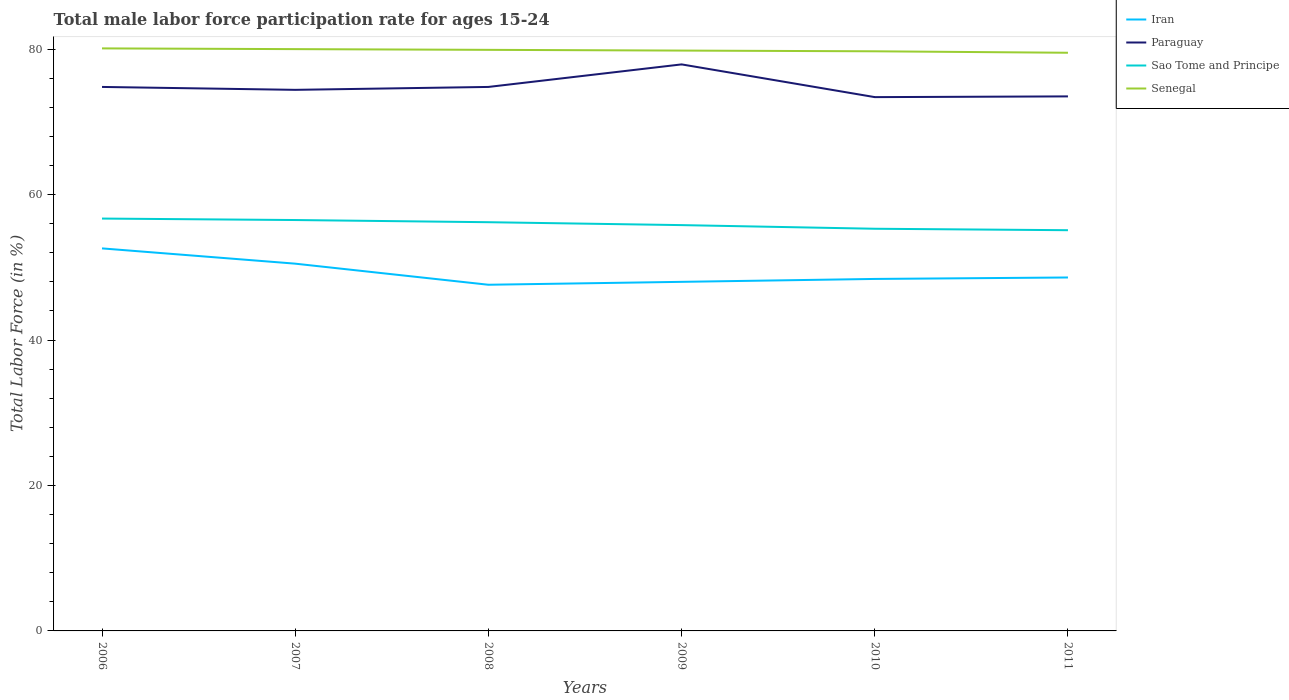How many different coloured lines are there?
Offer a very short reply. 4. Does the line corresponding to Iran intersect with the line corresponding to Senegal?
Provide a succinct answer. No. Across all years, what is the maximum male labor force participation rate in Sao Tome and Principe?
Offer a very short reply. 55.1. In which year was the male labor force participation rate in Paraguay maximum?
Give a very brief answer. 2010. What is the total male labor force participation rate in Sao Tome and Principe in the graph?
Ensure brevity in your answer.  0.3. What is the difference between the highest and the second highest male labor force participation rate in Sao Tome and Principe?
Offer a terse response. 1.6. What is the difference between the highest and the lowest male labor force participation rate in Senegal?
Provide a succinct answer. 3. How many legend labels are there?
Offer a very short reply. 4. What is the title of the graph?
Your response must be concise. Total male labor force participation rate for ages 15-24. What is the Total Labor Force (in %) of Iran in 2006?
Your answer should be very brief. 52.6. What is the Total Labor Force (in %) of Paraguay in 2006?
Your response must be concise. 74.8. What is the Total Labor Force (in %) in Sao Tome and Principe in 2006?
Make the answer very short. 56.7. What is the Total Labor Force (in %) of Senegal in 2006?
Provide a succinct answer. 80.1. What is the Total Labor Force (in %) in Iran in 2007?
Provide a short and direct response. 50.5. What is the Total Labor Force (in %) in Paraguay in 2007?
Provide a short and direct response. 74.4. What is the Total Labor Force (in %) of Sao Tome and Principe in 2007?
Your answer should be compact. 56.5. What is the Total Labor Force (in %) in Iran in 2008?
Your answer should be very brief. 47.6. What is the Total Labor Force (in %) of Paraguay in 2008?
Offer a terse response. 74.8. What is the Total Labor Force (in %) of Sao Tome and Principe in 2008?
Ensure brevity in your answer.  56.2. What is the Total Labor Force (in %) in Senegal in 2008?
Offer a terse response. 79.9. What is the Total Labor Force (in %) in Iran in 2009?
Keep it short and to the point. 48. What is the Total Labor Force (in %) of Paraguay in 2009?
Provide a succinct answer. 77.9. What is the Total Labor Force (in %) in Sao Tome and Principe in 2009?
Your answer should be compact. 55.8. What is the Total Labor Force (in %) in Senegal in 2009?
Your answer should be compact. 79.8. What is the Total Labor Force (in %) of Iran in 2010?
Your answer should be compact. 48.4. What is the Total Labor Force (in %) in Paraguay in 2010?
Offer a very short reply. 73.4. What is the Total Labor Force (in %) in Sao Tome and Principe in 2010?
Give a very brief answer. 55.3. What is the Total Labor Force (in %) of Senegal in 2010?
Ensure brevity in your answer.  79.7. What is the Total Labor Force (in %) of Iran in 2011?
Offer a very short reply. 48.6. What is the Total Labor Force (in %) in Paraguay in 2011?
Make the answer very short. 73.5. What is the Total Labor Force (in %) of Sao Tome and Principe in 2011?
Give a very brief answer. 55.1. What is the Total Labor Force (in %) in Senegal in 2011?
Your response must be concise. 79.5. Across all years, what is the maximum Total Labor Force (in %) in Iran?
Offer a terse response. 52.6. Across all years, what is the maximum Total Labor Force (in %) of Paraguay?
Give a very brief answer. 77.9. Across all years, what is the maximum Total Labor Force (in %) in Sao Tome and Principe?
Give a very brief answer. 56.7. Across all years, what is the maximum Total Labor Force (in %) in Senegal?
Provide a short and direct response. 80.1. Across all years, what is the minimum Total Labor Force (in %) in Iran?
Keep it short and to the point. 47.6. Across all years, what is the minimum Total Labor Force (in %) in Paraguay?
Offer a terse response. 73.4. Across all years, what is the minimum Total Labor Force (in %) in Sao Tome and Principe?
Your response must be concise. 55.1. Across all years, what is the minimum Total Labor Force (in %) in Senegal?
Provide a short and direct response. 79.5. What is the total Total Labor Force (in %) in Iran in the graph?
Provide a short and direct response. 295.7. What is the total Total Labor Force (in %) in Paraguay in the graph?
Make the answer very short. 448.8. What is the total Total Labor Force (in %) of Sao Tome and Principe in the graph?
Offer a very short reply. 335.6. What is the total Total Labor Force (in %) in Senegal in the graph?
Make the answer very short. 479. What is the difference between the Total Labor Force (in %) of Iran in 2006 and that in 2008?
Make the answer very short. 5. What is the difference between the Total Labor Force (in %) in Senegal in 2006 and that in 2008?
Provide a succinct answer. 0.2. What is the difference between the Total Labor Force (in %) in Iran in 2006 and that in 2009?
Make the answer very short. 4.6. What is the difference between the Total Labor Force (in %) of Paraguay in 2006 and that in 2009?
Give a very brief answer. -3.1. What is the difference between the Total Labor Force (in %) in Sao Tome and Principe in 2006 and that in 2009?
Your answer should be very brief. 0.9. What is the difference between the Total Labor Force (in %) in Iran in 2006 and that in 2010?
Offer a very short reply. 4.2. What is the difference between the Total Labor Force (in %) in Paraguay in 2006 and that in 2011?
Make the answer very short. 1.3. What is the difference between the Total Labor Force (in %) of Sao Tome and Principe in 2006 and that in 2011?
Your response must be concise. 1.6. What is the difference between the Total Labor Force (in %) of Iran in 2007 and that in 2008?
Make the answer very short. 2.9. What is the difference between the Total Labor Force (in %) in Senegal in 2007 and that in 2008?
Give a very brief answer. 0.1. What is the difference between the Total Labor Force (in %) of Iran in 2007 and that in 2009?
Keep it short and to the point. 2.5. What is the difference between the Total Labor Force (in %) of Senegal in 2007 and that in 2009?
Offer a terse response. 0.2. What is the difference between the Total Labor Force (in %) of Paraguay in 2007 and that in 2010?
Your answer should be compact. 1. What is the difference between the Total Labor Force (in %) in Senegal in 2007 and that in 2010?
Provide a succinct answer. 0.3. What is the difference between the Total Labor Force (in %) in Paraguay in 2007 and that in 2011?
Make the answer very short. 0.9. What is the difference between the Total Labor Force (in %) in Sao Tome and Principe in 2007 and that in 2011?
Make the answer very short. 1.4. What is the difference between the Total Labor Force (in %) in Senegal in 2007 and that in 2011?
Offer a very short reply. 0.5. What is the difference between the Total Labor Force (in %) of Iran in 2008 and that in 2009?
Offer a very short reply. -0.4. What is the difference between the Total Labor Force (in %) of Paraguay in 2008 and that in 2009?
Make the answer very short. -3.1. What is the difference between the Total Labor Force (in %) of Sao Tome and Principe in 2008 and that in 2009?
Offer a very short reply. 0.4. What is the difference between the Total Labor Force (in %) of Senegal in 2008 and that in 2009?
Provide a succinct answer. 0.1. What is the difference between the Total Labor Force (in %) of Iran in 2008 and that in 2010?
Your answer should be very brief. -0.8. What is the difference between the Total Labor Force (in %) in Sao Tome and Principe in 2008 and that in 2010?
Ensure brevity in your answer.  0.9. What is the difference between the Total Labor Force (in %) in Senegal in 2008 and that in 2010?
Provide a succinct answer. 0.2. What is the difference between the Total Labor Force (in %) in Iran in 2008 and that in 2011?
Offer a very short reply. -1. What is the difference between the Total Labor Force (in %) in Iran in 2009 and that in 2010?
Provide a short and direct response. -0.4. What is the difference between the Total Labor Force (in %) in Paraguay in 2009 and that in 2010?
Provide a short and direct response. 4.5. What is the difference between the Total Labor Force (in %) of Sao Tome and Principe in 2009 and that in 2010?
Give a very brief answer. 0.5. What is the difference between the Total Labor Force (in %) of Iran in 2009 and that in 2011?
Provide a succinct answer. -0.6. What is the difference between the Total Labor Force (in %) of Iran in 2010 and that in 2011?
Your answer should be very brief. -0.2. What is the difference between the Total Labor Force (in %) in Sao Tome and Principe in 2010 and that in 2011?
Make the answer very short. 0.2. What is the difference between the Total Labor Force (in %) of Senegal in 2010 and that in 2011?
Provide a succinct answer. 0.2. What is the difference between the Total Labor Force (in %) in Iran in 2006 and the Total Labor Force (in %) in Paraguay in 2007?
Keep it short and to the point. -21.8. What is the difference between the Total Labor Force (in %) of Iran in 2006 and the Total Labor Force (in %) of Senegal in 2007?
Give a very brief answer. -27.4. What is the difference between the Total Labor Force (in %) of Paraguay in 2006 and the Total Labor Force (in %) of Sao Tome and Principe in 2007?
Provide a succinct answer. 18.3. What is the difference between the Total Labor Force (in %) in Sao Tome and Principe in 2006 and the Total Labor Force (in %) in Senegal in 2007?
Offer a terse response. -23.3. What is the difference between the Total Labor Force (in %) in Iran in 2006 and the Total Labor Force (in %) in Paraguay in 2008?
Your response must be concise. -22.2. What is the difference between the Total Labor Force (in %) in Iran in 2006 and the Total Labor Force (in %) in Senegal in 2008?
Offer a very short reply. -27.3. What is the difference between the Total Labor Force (in %) of Paraguay in 2006 and the Total Labor Force (in %) of Sao Tome and Principe in 2008?
Provide a short and direct response. 18.6. What is the difference between the Total Labor Force (in %) in Sao Tome and Principe in 2006 and the Total Labor Force (in %) in Senegal in 2008?
Make the answer very short. -23.2. What is the difference between the Total Labor Force (in %) of Iran in 2006 and the Total Labor Force (in %) of Paraguay in 2009?
Make the answer very short. -25.3. What is the difference between the Total Labor Force (in %) of Iran in 2006 and the Total Labor Force (in %) of Senegal in 2009?
Your answer should be very brief. -27.2. What is the difference between the Total Labor Force (in %) in Sao Tome and Principe in 2006 and the Total Labor Force (in %) in Senegal in 2009?
Ensure brevity in your answer.  -23.1. What is the difference between the Total Labor Force (in %) in Iran in 2006 and the Total Labor Force (in %) in Paraguay in 2010?
Provide a succinct answer. -20.8. What is the difference between the Total Labor Force (in %) in Iran in 2006 and the Total Labor Force (in %) in Senegal in 2010?
Ensure brevity in your answer.  -27.1. What is the difference between the Total Labor Force (in %) of Iran in 2006 and the Total Labor Force (in %) of Paraguay in 2011?
Offer a very short reply. -20.9. What is the difference between the Total Labor Force (in %) of Iran in 2006 and the Total Labor Force (in %) of Sao Tome and Principe in 2011?
Your answer should be compact. -2.5. What is the difference between the Total Labor Force (in %) in Iran in 2006 and the Total Labor Force (in %) in Senegal in 2011?
Ensure brevity in your answer.  -26.9. What is the difference between the Total Labor Force (in %) of Paraguay in 2006 and the Total Labor Force (in %) of Senegal in 2011?
Provide a short and direct response. -4.7. What is the difference between the Total Labor Force (in %) in Sao Tome and Principe in 2006 and the Total Labor Force (in %) in Senegal in 2011?
Your answer should be very brief. -22.8. What is the difference between the Total Labor Force (in %) of Iran in 2007 and the Total Labor Force (in %) of Paraguay in 2008?
Give a very brief answer. -24.3. What is the difference between the Total Labor Force (in %) in Iran in 2007 and the Total Labor Force (in %) in Sao Tome and Principe in 2008?
Offer a terse response. -5.7. What is the difference between the Total Labor Force (in %) in Iran in 2007 and the Total Labor Force (in %) in Senegal in 2008?
Ensure brevity in your answer.  -29.4. What is the difference between the Total Labor Force (in %) of Sao Tome and Principe in 2007 and the Total Labor Force (in %) of Senegal in 2008?
Your answer should be very brief. -23.4. What is the difference between the Total Labor Force (in %) in Iran in 2007 and the Total Labor Force (in %) in Paraguay in 2009?
Provide a succinct answer. -27.4. What is the difference between the Total Labor Force (in %) of Iran in 2007 and the Total Labor Force (in %) of Senegal in 2009?
Your response must be concise. -29.3. What is the difference between the Total Labor Force (in %) in Paraguay in 2007 and the Total Labor Force (in %) in Senegal in 2009?
Provide a succinct answer. -5.4. What is the difference between the Total Labor Force (in %) in Sao Tome and Principe in 2007 and the Total Labor Force (in %) in Senegal in 2009?
Keep it short and to the point. -23.3. What is the difference between the Total Labor Force (in %) of Iran in 2007 and the Total Labor Force (in %) of Paraguay in 2010?
Ensure brevity in your answer.  -22.9. What is the difference between the Total Labor Force (in %) in Iran in 2007 and the Total Labor Force (in %) in Senegal in 2010?
Give a very brief answer. -29.2. What is the difference between the Total Labor Force (in %) in Paraguay in 2007 and the Total Labor Force (in %) in Sao Tome and Principe in 2010?
Provide a short and direct response. 19.1. What is the difference between the Total Labor Force (in %) of Sao Tome and Principe in 2007 and the Total Labor Force (in %) of Senegal in 2010?
Ensure brevity in your answer.  -23.2. What is the difference between the Total Labor Force (in %) in Iran in 2007 and the Total Labor Force (in %) in Senegal in 2011?
Offer a terse response. -29. What is the difference between the Total Labor Force (in %) of Paraguay in 2007 and the Total Labor Force (in %) of Sao Tome and Principe in 2011?
Make the answer very short. 19.3. What is the difference between the Total Labor Force (in %) of Iran in 2008 and the Total Labor Force (in %) of Paraguay in 2009?
Offer a terse response. -30.3. What is the difference between the Total Labor Force (in %) of Iran in 2008 and the Total Labor Force (in %) of Senegal in 2009?
Keep it short and to the point. -32.2. What is the difference between the Total Labor Force (in %) of Paraguay in 2008 and the Total Labor Force (in %) of Sao Tome and Principe in 2009?
Give a very brief answer. 19. What is the difference between the Total Labor Force (in %) in Paraguay in 2008 and the Total Labor Force (in %) in Senegal in 2009?
Offer a terse response. -5. What is the difference between the Total Labor Force (in %) in Sao Tome and Principe in 2008 and the Total Labor Force (in %) in Senegal in 2009?
Your answer should be compact. -23.6. What is the difference between the Total Labor Force (in %) of Iran in 2008 and the Total Labor Force (in %) of Paraguay in 2010?
Give a very brief answer. -25.8. What is the difference between the Total Labor Force (in %) in Iran in 2008 and the Total Labor Force (in %) in Sao Tome and Principe in 2010?
Provide a short and direct response. -7.7. What is the difference between the Total Labor Force (in %) in Iran in 2008 and the Total Labor Force (in %) in Senegal in 2010?
Make the answer very short. -32.1. What is the difference between the Total Labor Force (in %) in Paraguay in 2008 and the Total Labor Force (in %) in Sao Tome and Principe in 2010?
Provide a short and direct response. 19.5. What is the difference between the Total Labor Force (in %) of Sao Tome and Principe in 2008 and the Total Labor Force (in %) of Senegal in 2010?
Give a very brief answer. -23.5. What is the difference between the Total Labor Force (in %) of Iran in 2008 and the Total Labor Force (in %) of Paraguay in 2011?
Your answer should be compact. -25.9. What is the difference between the Total Labor Force (in %) in Iran in 2008 and the Total Labor Force (in %) in Sao Tome and Principe in 2011?
Provide a succinct answer. -7.5. What is the difference between the Total Labor Force (in %) of Iran in 2008 and the Total Labor Force (in %) of Senegal in 2011?
Offer a terse response. -31.9. What is the difference between the Total Labor Force (in %) in Paraguay in 2008 and the Total Labor Force (in %) in Sao Tome and Principe in 2011?
Offer a terse response. 19.7. What is the difference between the Total Labor Force (in %) of Paraguay in 2008 and the Total Labor Force (in %) of Senegal in 2011?
Provide a short and direct response. -4.7. What is the difference between the Total Labor Force (in %) of Sao Tome and Principe in 2008 and the Total Labor Force (in %) of Senegal in 2011?
Your answer should be very brief. -23.3. What is the difference between the Total Labor Force (in %) in Iran in 2009 and the Total Labor Force (in %) in Paraguay in 2010?
Give a very brief answer. -25.4. What is the difference between the Total Labor Force (in %) of Iran in 2009 and the Total Labor Force (in %) of Sao Tome and Principe in 2010?
Your answer should be compact. -7.3. What is the difference between the Total Labor Force (in %) in Iran in 2009 and the Total Labor Force (in %) in Senegal in 2010?
Offer a very short reply. -31.7. What is the difference between the Total Labor Force (in %) of Paraguay in 2009 and the Total Labor Force (in %) of Sao Tome and Principe in 2010?
Your answer should be very brief. 22.6. What is the difference between the Total Labor Force (in %) of Paraguay in 2009 and the Total Labor Force (in %) of Senegal in 2010?
Offer a very short reply. -1.8. What is the difference between the Total Labor Force (in %) in Sao Tome and Principe in 2009 and the Total Labor Force (in %) in Senegal in 2010?
Keep it short and to the point. -23.9. What is the difference between the Total Labor Force (in %) in Iran in 2009 and the Total Labor Force (in %) in Paraguay in 2011?
Your answer should be compact. -25.5. What is the difference between the Total Labor Force (in %) in Iran in 2009 and the Total Labor Force (in %) in Senegal in 2011?
Offer a terse response. -31.5. What is the difference between the Total Labor Force (in %) of Paraguay in 2009 and the Total Labor Force (in %) of Sao Tome and Principe in 2011?
Provide a succinct answer. 22.8. What is the difference between the Total Labor Force (in %) of Paraguay in 2009 and the Total Labor Force (in %) of Senegal in 2011?
Offer a very short reply. -1.6. What is the difference between the Total Labor Force (in %) in Sao Tome and Principe in 2009 and the Total Labor Force (in %) in Senegal in 2011?
Your answer should be compact. -23.7. What is the difference between the Total Labor Force (in %) in Iran in 2010 and the Total Labor Force (in %) in Paraguay in 2011?
Offer a terse response. -25.1. What is the difference between the Total Labor Force (in %) of Iran in 2010 and the Total Labor Force (in %) of Sao Tome and Principe in 2011?
Make the answer very short. -6.7. What is the difference between the Total Labor Force (in %) in Iran in 2010 and the Total Labor Force (in %) in Senegal in 2011?
Offer a very short reply. -31.1. What is the difference between the Total Labor Force (in %) in Sao Tome and Principe in 2010 and the Total Labor Force (in %) in Senegal in 2011?
Your response must be concise. -24.2. What is the average Total Labor Force (in %) of Iran per year?
Ensure brevity in your answer.  49.28. What is the average Total Labor Force (in %) in Paraguay per year?
Offer a very short reply. 74.8. What is the average Total Labor Force (in %) of Sao Tome and Principe per year?
Your answer should be compact. 55.93. What is the average Total Labor Force (in %) of Senegal per year?
Make the answer very short. 79.83. In the year 2006, what is the difference between the Total Labor Force (in %) in Iran and Total Labor Force (in %) in Paraguay?
Ensure brevity in your answer.  -22.2. In the year 2006, what is the difference between the Total Labor Force (in %) of Iran and Total Labor Force (in %) of Senegal?
Ensure brevity in your answer.  -27.5. In the year 2006, what is the difference between the Total Labor Force (in %) of Paraguay and Total Labor Force (in %) of Sao Tome and Principe?
Keep it short and to the point. 18.1. In the year 2006, what is the difference between the Total Labor Force (in %) of Sao Tome and Principe and Total Labor Force (in %) of Senegal?
Offer a very short reply. -23.4. In the year 2007, what is the difference between the Total Labor Force (in %) in Iran and Total Labor Force (in %) in Paraguay?
Make the answer very short. -23.9. In the year 2007, what is the difference between the Total Labor Force (in %) of Iran and Total Labor Force (in %) of Sao Tome and Principe?
Your response must be concise. -6. In the year 2007, what is the difference between the Total Labor Force (in %) of Iran and Total Labor Force (in %) of Senegal?
Your answer should be very brief. -29.5. In the year 2007, what is the difference between the Total Labor Force (in %) in Paraguay and Total Labor Force (in %) in Sao Tome and Principe?
Keep it short and to the point. 17.9. In the year 2007, what is the difference between the Total Labor Force (in %) of Sao Tome and Principe and Total Labor Force (in %) of Senegal?
Provide a succinct answer. -23.5. In the year 2008, what is the difference between the Total Labor Force (in %) of Iran and Total Labor Force (in %) of Paraguay?
Offer a terse response. -27.2. In the year 2008, what is the difference between the Total Labor Force (in %) in Iran and Total Labor Force (in %) in Senegal?
Offer a very short reply. -32.3. In the year 2008, what is the difference between the Total Labor Force (in %) in Paraguay and Total Labor Force (in %) in Senegal?
Offer a terse response. -5.1. In the year 2008, what is the difference between the Total Labor Force (in %) of Sao Tome and Principe and Total Labor Force (in %) of Senegal?
Offer a very short reply. -23.7. In the year 2009, what is the difference between the Total Labor Force (in %) of Iran and Total Labor Force (in %) of Paraguay?
Your answer should be compact. -29.9. In the year 2009, what is the difference between the Total Labor Force (in %) of Iran and Total Labor Force (in %) of Sao Tome and Principe?
Offer a terse response. -7.8. In the year 2009, what is the difference between the Total Labor Force (in %) of Iran and Total Labor Force (in %) of Senegal?
Your response must be concise. -31.8. In the year 2009, what is the difference between the Total Labor Force (in %) in Paraguay and Total Labor Force (in %) in Sao Tome and Principe?
Give a very brief answer. 22.1. In the year 2009, what is the difference between the Total Labor Force (in %) of Paraguay and Total Labor Force (in %) of Senegal?
Offer a terse response. -1.9. In the year 2009, what is the difference between the Total Labor Force (in %) of Sao Tome and Principe and Total Labor Force (in %) of Senegal?
Make the answer very short. -24. In the year 2010, what is the difference between the Total Labor Force (in %) of Iran and Total Labor Force (in %) of Paraguay?
Provide a short and direct response. -25. In the year 2010, what is the difference between the Total Labor Force (in %) in Iran and Total Labor Force (in %) in Senegal?
Ensure brevity in your answer.  -31.3. In the year 2010, what is the difference between the Total Labor Force (in %) of Paraguay and Total Labor Force (in %) of Senegal?
Offer a terse response. -6.3. In the year 2010, what is the difference between the Total Labor Force (in %) in Sao Tome and Principe and Total Labor Force (in %) in Senegal?
Your answer should be very brief. -24.4. In the year 2011, what is the difference between the Total Labor Force (in %) in Iran and Total Labor Force (in %) in Paraguay?
Offer a terse response. -24.9. In the year 2011, what is the difference between the Total Labor Force (in %) in Iran and Total Labor Force (in %) in Senegal?
Give a very brief answer. -30.9. In the year 2011, what is the difference between the Total Labor Force (in %) of Paraguay and Total Labor Force (in %) of Sao Tome and Principe?
Your response must be concise. 18.4. In the year 2011, what is the difference between the Total Labor Force (in %) in Sao Tome and Principe and Total Labor Force (in %) in Senegal?
Provide a succinct answer. -24.4. What is the ratio of the Total Labor Force (in %) in Iran in 2006 to that in 2007?
Your answer should be compact. 1.04. What is the ratio of the Total Labor Force (in %) of Paraguay in 2006 to that in 2007?
Ensure brevity in your answer.  1.01. What is the ratio of the Total Labor Force (in %) in Sao Tome and Principe in 2006 to that in 2007?
Ensure brevity in your answer.  1. What is the ratio of the Total Labor Force (in %) in Iran in 2006 to that in 2008?
Your response must be concise. 1.1. What is the ratio of the Total Labor Force (in %) in Sao Tome and Principe in 2006 to that in 2008?
Keep it short and to the point. 1.01. What is the ratio of the Total Labor Force (in %) in Iran in 2006 to that in 2009?
Offer a terse response. 1.1. What is the ratio of the Total Labor Force (in %) in Paraguay in 2006 to that in 2009?
Provide a succinct answer. 0.96. What is the ratio of the Total Labor Force (in %) in Sao Tome and Principe in 2006 to that in 2009?
Ensure brevity in your answer.  1.02. What is the ratio of the Total Labor Force (in %) in Iran in 2006 to that in 2010?
Your answer should be compact. 1.09. What is the ratio of the Total Labor Force (in %) in Paraguay in 2006 to that in 2010?
Provide a short and direct response. 1.02. What is the ratio of the Total Labor Force (in %) in Sao Tome and Principe in 2006 to that in 2010?
Provide a succinct answer. 1.03. What is the ratio of the Total Labor Force (in %) of Senegal in 2006 to that in 2010?
Your answer should be compact. 1. What is the ratio of the Total Labor Force (in %) in Iran in 2006 to that in 2011?
Offer a very short reply. 1.08. What is the ratio of the Total Labor Force (in %) of Paraguay in 2006 to that in 2011?
Provide a succinct answer. 1.02. What is the ratio of the Total Labor Force (in %) in Sao Tome and Principe in 2006 to that in 2011?
Make the answer very short. 1.03. What is the ratio of the Total Labor Force (in %) of Senegal in 2006 to that in 2011?
Make the answer very short. 1.01. What is the ratio of the Total Labor Force (in %) in Iran in 2007 to that in 2008?
Your response must be concise. 1.06. What is the ratio of the Total Labor Force (in %) in Sao Tome and Principe in 2007 to that in 2008?
Keep it short and to the point. 1.01. What is the ratio of the Total Labor Force (in %) of Senegal in 2007 to that in 2008?
Provide a short and direct response. 1. What is the ratio of the Total Labor Force (in %) in Iran in 2007 to that in 2009?
Offer a terse response. 1.05. What is the ratio of the Total Labor Force (in %) of Paraguay in 2007 to that in 2009?
Your answer should be very brief. 0.96. What is the ratio of the Total Labor Force (in %) in Sao Tome and Principe in 2007 to that in 2009?
Offer a terse response. 1.01. What is the ratio of the Total Labor Force (in %) of Iran in 2007 to that in 2010?
Your response must be concise. 1.04. What is the ratio of the Total Labor Force (in %) of Paraguay in 2007 to that in 2010?
Ensure brevity in your answer.  1.01. What is the ratio of the Total Labor Force (in %) in Sao Tome and Principe in 2007 to that in 2010?
Offer a terse response. 1.02. What is the ratio of the Total Labor Force (in %) of Iran in 2007 to that in 2011?
Keep it short and to the point. 1.04. What is the ratio of the Total Labor Force (in %) in Paraguay in 2007 to that in 2011?
Provide a succinct answer. 1.01. What is the ratio of the Total Labor Force (in %) of Sao Tome and Principe in 2007 to that in 2011?
Ensure brevity in your answer.  1.03. What is the ratio of the Total Labor Force (in %) in Iran in 2008 to that in 2009?
Keep it short and to the point. 0.99. What is the ratio of the Total Labor Force (in %) in Paraguay in 2008 to that in 2009?
Provide a short and direct response. 0.96. What is the ratio of the Total Labor Force (in %) in Sao Tome and Principe in 2008 to that in 2009?
Make the answer very short. 1.01. What is the ratio of the Total Labor Force (in %) of Senegal in 2008 to that in 2009?
Provide a succinct answer. 1. What is the ratio of the Total Labor Force (in %) in Iran in 2008 to that in 2010?
Ensure brevity in your answer.  0.98. What is the ratio of the Total Labor Force (in %) in Paraguay in 2008 to that in 2010?
Keep it short and to the point. 1.02. What is the ratio of the Total Labor Force (in %) in Sao Tome and Principe in 2008 to that in 2010?
Provide a short and direct response. 1.02. What is the ratio of the Total Labor Force (in %) of Iran in 2008 to that in 2011?
Provide a succinct answer. 0.98. What is the ratio of the Total Labor Force (in %) of Paraguay in 2008 to that in 2011?
Ensure brevity in your answer.  1.02. What is the ratio of the Total Labor Force (in %) of Iran in 2009 to that in 2010?
Your response must be concise. 0.99. What is the ratio of the Total Labor Force (in %) in Paraguay in 2009 to that in 2010?
Your response must be concise. 1.06. What is the ratio of the Total Labor Force (in %) of Paraguay in 2009 to that in 2011?
Keep it short and to the point. 1.06. What is the ratio of the Total Labor Force (in %) in Sao Tome and Principe in 2009 to that in 2011?
Give a very brief answer. 1.01. What is the ratio of the Total Labor Force (in %) of Iran in 2010 to that in 2011?
Your answer should be compact. 1. What is the ratio of the Total Labor Force (in %) of Paraguay in 2010 to that in 2011?
Your response must be concise. 1. What is the ratio of the Total Labor Force (in %) of Sao Tome and Principe in 2010 to that in 2011?
Provide a short and direct response. 1. What is the difference between the highest and the second highest Total Labor Force (in %) in Iran?
Offer a terse response. 2.1. What is the difference between the highest and the second highest Total Labor Force (in %) of Sao Tome and Principe?
Ensure brevity in your answer.  0.2. What is the difference between the highest and the lowest Total Labor Force (in %) in Iran?
Give a very brief answer. 5. What is the difference between the highest and the lowest Total Labor Force (in %) in Paraguay?
Your response must be concise. 4.5. 